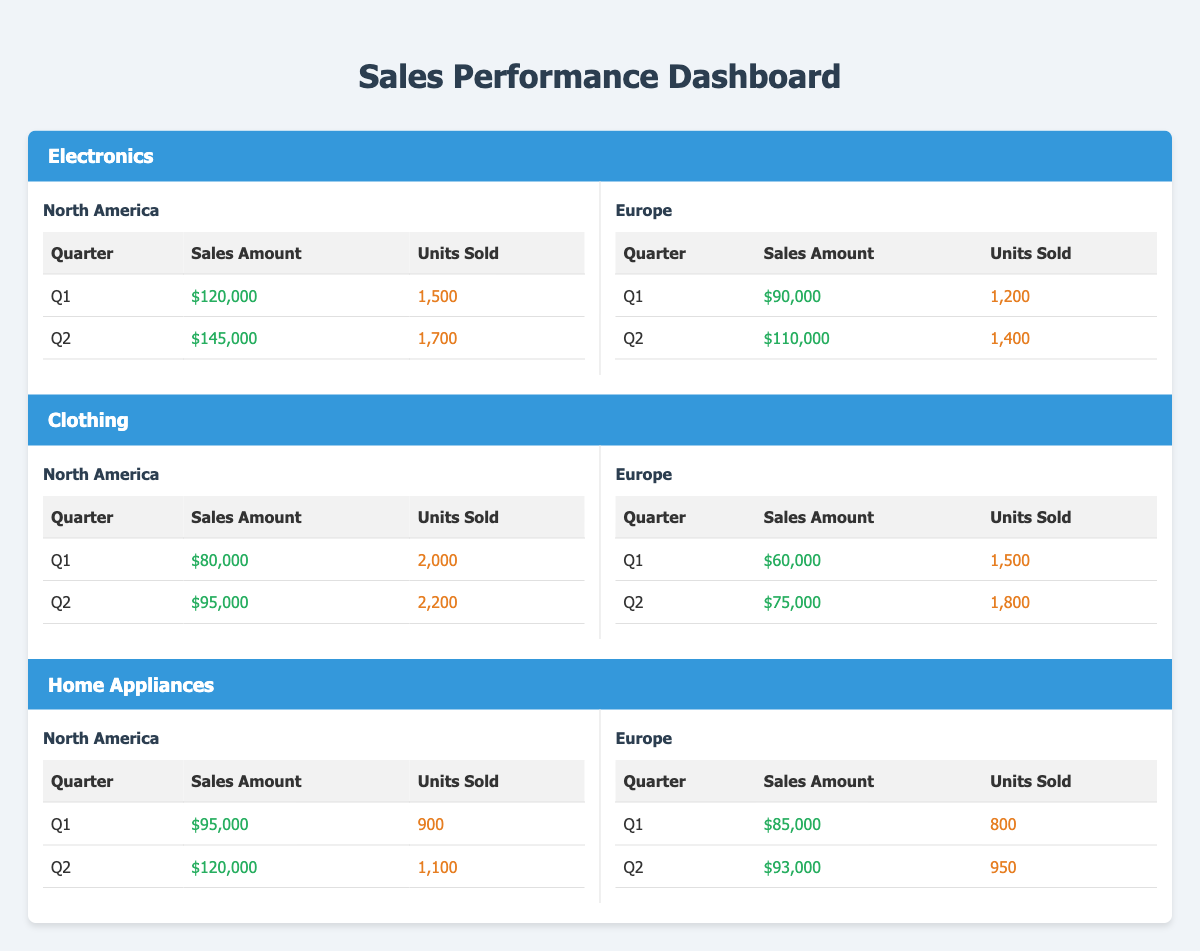What were the total sales amounts for Electronics in North America across Q1 and Q2? The sales amount in Q1 for Electronics in North America is $120,000 and in Q2 is $145,000. Adding these together gives us $120,000 + $145,000 = $265,000.
Answer: $265,000 Which region sold the most units in Q2 for Clothing? In Q2 for Clothing, North America sold 2,200 units while Europe sold 1,800 units. Comparing these two values, 2,200 is greater than 1,800, so North America sold the most units.
Answer: North America What is the sales amount for Home Appliances in Europe during Q1? The sales amount for Home Appliances in Europe during Q1 is $85,000, as indicated directly in the table.
Answer: $85,000 Is it true that more units were sold for Electronics in Q2 than for Clothing in Q2? In Q2, Electronics sold 1,700 units and Clothing sold 2,200 units. Since 1,700 is less than 2,200, the statement is false.
Answer: No What was the percentage increase in sales amount for Home Appliances from Q1 to Q2 in North America? In North America, the sales amount for Home Appliances in Q1 is $95,000 and in Q2 is $120,000. To find the percentage increase, subtract Q1 from Q2: $120,000 - $95,000 = $25,000. Then, divide the difference by the Q1 amount: $25,000 / $95,000 = 0.2632. To get the percentage, multiply by 100, which gives us approximately 26.32%.
Answer: 26.32% How many total units were sold for Electronics in Europe across both quarters? In Europe for Electronics, the units sold in Q1 is 1,200, and in Q2 is 1,400. Summing these gives 1,200 + 1,400 = 2,600 units.
Answer: 2,600 Which product category had the highest sales amount in North America for Q2? In North America for Q2, Electronics had a sales amount of $145,000, Clothing had $95,000, and Home Appliances had $120,000. Comparing these amounts, Electronics has the highest value.
Answer: Electronics Did Clothing or Home Appliances sell more units in Europe during Q2? In Europe for Q2, Clothing sold 1,800 units while Home Appliances sold 950 units. Since 1,800 is greater than 950, Clothing sold more units.
Answer: Yes What is the total sales amount for all product categories in North America for Q1? For North America in Q1, Electronics sold $120,000, Clothing sold $80,000, and Home Appliances sold $95,000. Adding these amounts gives us $120,000 + $80,000 + $95,000 = $295,000.
Answer: $295,000 